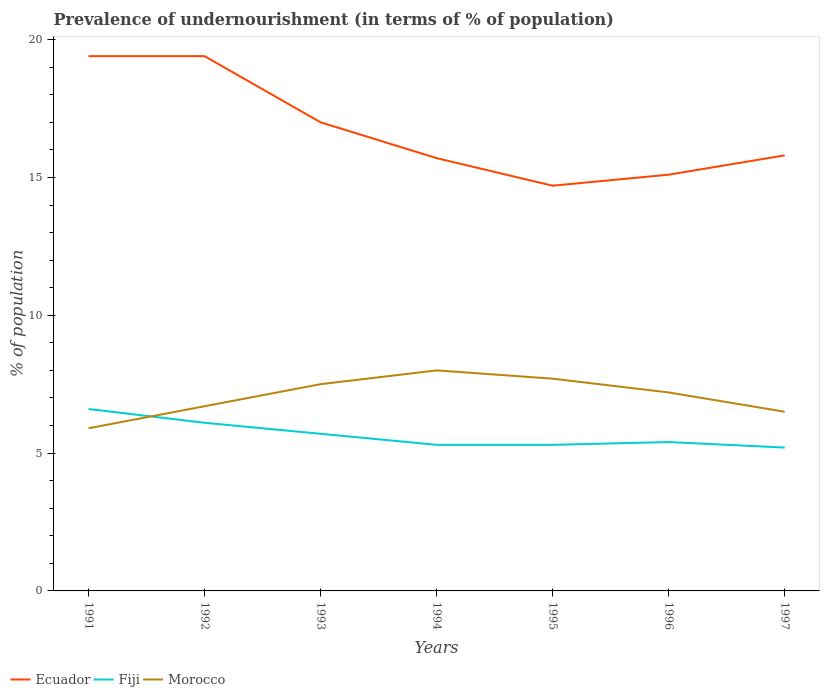Does the line corresponding to Morocco intersect with the line corresponding to Fiji?
Give a very brief answer. Yes. In which year was the percentage of undernourished population in Ecuador maximum?
Ensure brevity in your answer.  1995. What is the total percentage of undernourished population in Ecuador in the graph?
Your answer should be compact. 4.3. What is the difference between the highest and the second highest percentage of undernourished population in Morocco?
Provide a succinct answer. 2.1. What is the difference between the highest and the lowest percentage of undernourished population in Morocco?
Offer a terse response. 4. How many lines are there?
Your response must be concise. 3. How many years are there in the graph?
Keep it short and to the point. 7. What is the difference between two consecutive major ticks on the Y-axis?
Your response must be concise. 5. How many legend labels are there?
Your answer should be compact. 3. What is the title of the graph?
Your answer should be compact. Prevalence of undernourishment (in terms of % of population). Does "Panama" appear as one of the legend labels in the graph?
Your answer should be compact. No. What is the label or title of the X-axis?
Offer a terse response. Years. What is the label or title of the Y-axis?
Your answer should be compact. % of population. What is the % of population of Ecuador in 1991?
Offer a terse response. 19.4. What is the % of population in Fiji in 1991?
Offer a terse response. 6.6. What is the % of population of Morocco in 1991?
Your answer should be very brief. 5.9. What is the % of population in Fiji in 1992?
Your answer should be compact. 6.1. What is the % of population in Morocco in 1992?
Offer a very short reply. 6.7. What is the % of population of Fiji in 1993?
Offer a very short reply. 5.7. What is the % of population of Fiji in 1994?
Provide a succinct answer. 5.3. What is the % of population of Morocco in 1994?
Provide a short and direct response. 8. What is the % of population in Ecuador in 1995?
Keep it short and to the point. 14.7. What is the % of population of Fiji in 1995?
Provide a short and direct response. 5.3. What is the % of population in Morocco in 1995?
Ensure brevity in your answer.  7.7. What is the % of population of Ecuador in 1996?
Ensure brevity in your answer.  15.1. What is the % of population in Morocco in 1997?
Keep it short and to the point. 6.5. Across all years, what is the maximum % of population in Morocco?
Offer a terse response. 8. Across all years, what is the minimum % of population of Ecuador?
Your answer should be very brief. 14.7. Across all years, what is the minimum % of population of Fiji?
Provide a succinct answer. 5.2. Across all years, what is the minimum % of population of Morocco?
Offer a terse response. 5.9. What is the total % of population of Ecuador in the graph?
Your answer should be compact. 117.1. What is the total % of population of Fiji in the graph?
Keep it short and to the point. 39.6. What is the total % of population in Morocco in the graph?
Offer a very short reply. 49.5. What is the difference between the % of population in Ecuador in 1991 and that in 1992?
Your answer should be compact. 0. What is the difference between the % of population in Morocco in 1991 and that in 1992?
Offer a very short reply. -0.8. What is the difference between the % of population in Ecuador in 1991 and that in 1993?
Provide a short and direct response. 2.4. What is the difference between the % of population of Morocco in 1991 and that in 1993?
Give a very brief answer. -1.6. What is the difference between the % of population in Ecuador in 1991 and that in 1994?
Ensure brevity in your answer.  3.7. What is the difference between the % of population in Fiji in 1991 and that in 1995?
Your response must be concise. 1.3. What is the difference between the % of population in Morocco in 1991 and that in 1996?
Your answer should be very brief. -1.3. What is the difference between the % of population of Fiji in 1991 and that in 1997?
Your answer should be compact. 1.4. What is the difference between the % of population of Morocco in 1991 and that in 1997?
Your response must be concise. -0.6. What is the difference between the % of population in Ecuador in 1992 and that in 1993?
Your answer should be compact. 2.4. What is the difference between the % of population of Fiji in 1992 and that in 1993?
Your answer should be compact. 0.4. What is the difference between the % of population in Morocco in 1992 and that in 1993?
Make the answer very short. -0.8. What is the difference between the % of population of Fiji in 1992 and that in 1996?
Provide a succinct answer. 0.7. What is the difference between the % of population of Morocco in 1992 and that in 1996?
Provide a short and direct response. -0.5. What is the difference between the % of population of Fiji in 1992 and that in 1997?
Make the answer very short. 0.9. What is the difference between the % of population of Ecuador in 1993 and that in 1994?
Give a very brief answer. 1.3. What is the difference between the % of population of Fiji in 1993 and that in 1994?
Provide a succinct answer. 0.4. What is the difference between the % of population in Fiji in 1993 and that in 1995?
Make the answer very short. 0.4. What is the difference between the % of population of Morocco in 1993 and that in 1995?
Keep it short and to the point. -0.2. What is the difference between the % of population of Morocco in 1993 and that in 1996?
Provide a succinct answer. 0.3. What is the difference between the % of population of Ecuador in 1993 and that in 1997?
Your answer should be very brief. 1.2. What is the difference between the % of population of Ecuador in 1994 and that in 1995?
Ensure brevity in your answer.  1. What is the difference between the % of population of Fiji in 1994 and that in 1995?
Your response must be concise. 0. What is the difference between the % of population of Fiji in 1994 and that in 1996?
Your answer should be compact. -0.1. What is the difference between the % of population in Morocco in 1994 and that in 1997?
Make the answer very short. 1.5. What is the difference between the % of population in Ecuador in 1995 and that in 1996?
Offer a terse response. -0.4. What is the difference between the % of population of Morocco in 1995 and that in 1996?
Give a very brief answer. 0.5. What is the difference between the % of population in Ecuador in 1995 and that in 1997?
Keep it short and to the point. -1.1. What is the difference between the % of population in Fiji in 1995 and that in 1997?
Your answer should be compact. 0.1. What is the difference between the % of population of Morocco in 1995 and that in 1997?
Make the answer very short. 1.2. What is the difference between the % of population in Fiji in 1996 and that in 1997?
Keep it short and to the point. 0.2. What is the difference between the % of population in Morocco in 1996 and that in 1997?
Ensure brevity in your answer.  0.7. What is the difference between the % of population of Ecuador in 1991 and the % of population of Morocco in 1992?
Your answer should be very brief. 12.7. What is the difference between the % of population of Fiji in 1991 and the % of population of Morocco in 1992?
Your response must be concise. -0.1. What is the difference between the % of population of Ecuador in 1991 and the % of population of Fiji in 1993?
Provide a short and direct response. 13.7. What is the difference between the % of population in Ecuador in 1991 and the % of population in Morocco in 1993?
Your answer should be very brief. 11.9. What is the difference between the % of population in Fiji in 1991 and the % of population in Morocco in 1993?
Your response must be concise. -0.9. What is the difference between the % of population in Ecuador in 1991 and the % of population in Fiji in 1994?
Provide a succinct answer. 14.1. What is the difference between the % of population in Ecuador in 1991 and the % of population in Morocco in 1994?
Make the answer very short. 11.4. What is the difference between the % of population in Ecuador in 1991 and the % of population in Fiji in 1995?
Provide a short and direct response. 14.1. What is the difference between the % of population in Ecuador in 1991 and the % of population in Fiji in 1996?
Your response must be concise. 14. What is the difference between the % of population in Ecuador in 1991 and the % of population in Fiji in 1997?
Give a very brief answer. 14.2. What is the difference between the % of population in Ecuador in 1991 and the % of population in Morocco in 1997?
Provide a short and direct response. 12.9. What is the difference between the % of population of Fiji in 1991 and the % of population of Morocco in 1997?
Keep it short and to the point. 0.1. What is the difference between the % of population in Ecuador in 1992 and the % of population in Morocco in 1993?
Your answer should be compact. 11.9. What is the difference between the % of population in Ecuador in 1992 and the % of population in Fiji in 1994?
Offer a terse response. 14.1. What is the difference between the % of population in Ecuador in 1992 and the % of population in Morocco in 1994?
Provide a short and direct response. 11.4. What is the difference between the % of population of Ecuador in 1992 and the % of population of Fiji in 1995?
Your answer should be very brief. 14.1. What is the difference between the % of population of Ecuador in 1992 and the % of population of Fiji in 1996?
Make the answer very short. 14. What is the difference between the % of population in Ecuador in 1992 and the % of population in Fiji in 1997?
Your answer should be compact. 14.2. What is the difference between the % of population in Ecuador in 1992 and the % of population in Morocco in 1997?
Give a very brief answer. 12.9. What is the difference between the % of population in Fiji in 1992 and the % of population in Morocco in 1997?
Offer a terse response. -0.4. What is the difference between the % of population of Ecuador in 1993 and the % of population of Fiji in 1994?
Provide a succinct answer. 11.7. What is the difference between the % of population in Ecuador in 1993 and the % of population in Morocco in 1994?
Provide a short and direct response. 9. What is the difference between the % of population in Fiji in 1993 and the % of population in Morocco in 1994?
Ensure brevity in your answer.  -2.3. What is the difference between the % of population in Ecuador in 1993 and the % of population in Morocco in 1995?
Your response must be concise. 9.3. What is the difference between the % of population of Ecuador in 1993 and the % of population of Morocco in 1996?
Your answer should be very brief. 9.8. What is the difference between the % of population of Ecuador in 1993 and the % of population of Fiji in 1997?
Make the answer very short. 11.8. What is the difference between the % of population in Ecuador in 1993 and the % of population in Morocco in 1997?
Offer a terse response. 10.5. What is the difference between the % of population of Fiji in 1993 and the % of population of Morocco in 1997?
Ensure brevity in your answer.  -0.8. What is the difference between the % of population in Ecuador in 1994 and the % of population in Fiji in 1995?
Offer a terse response. 10.4. What is the difference between the % of population in Ecuador in 1994 and the % of population in Morocco in 1995?
Make the answer very short. 8. What is the difference between the % of population of Ecuador in 1994 and the % of population of Fiji in 1996?
Your answer should be compact. 10.3. What is the difference between the % of population of Ecuador in 1994 and the % of population of Morocco in 1996?
Provide a succinct answer. 8.5. What is the difference between the % of population in Fiji in 1994 and the % of population in Morocco in 1996?
Make the answer very short. -1.9. What is the difference between the % of population of Ecuador in 1994 and the % of population of Fiji in 1997?
Your answer should be compact. 10.5. What is the difference between the % of population in Ecuador in 1994 and the % of population in Morocco in 1997?
Offer a terse response. 9.2. What is the difference between the % of population in Fiji in 1994 and the % of population in Morocco in 1997?
Give a very brief answer. -1.2. What is the difference between the % of population of Ecuador in 1995 and the % of population of Fiji in 1996?
Your answer should be very brief. 9.3. What is the difference between the % of population in Fiji in 1995 and the % of population in Morocco in 1996?
Give a very brief answer. -1.9. What is the difference between the % of population in Ecuador in 1995 and the % of population in Morocco in 1997?
Provide a short and direct response. 8.2. What is the difference between the % of population in Ecuador in 1996 and the % of population in Morocco in 1997?
Your answer should be very brief. 8.6. What is the difference between the % of population of Fiji in 1996 and the % of population of Morocco in 1997?
Your response must be concise. -1.1. What is the average % of population of Ecuador per year?
Offer a terse response. 16.73. What is the average % of population of Fiji per year?
Offer a very short reply. 5.66. What is the average % of population of Morocco per year?
Your answer should be very brief. 7.07. In the year 1991, what is the difference between the % of population in Ecuador and % of population in Fiji?
Your answer should be very brief. 12.8. In the year 1991, what is the difference between the % of population of Ecuador and % of population of Morocco?
Provide a short and direct response. 13.5. In the year 1992, what is the difference between the % of population of Ecuador and % of population of Morocco?
Provide a succinct answer. 12.7. In the year 1992, what is the difference between the % of population of Fiji and % of population of Morocco?
Keep it short and to the point. -0.6. In the year 1993, what is the difference between the % of population in Ecuador and % of population in Fiji?
Provide a succinct answer. 11.3. In the year 1993, what is the difference between the % of population of Ecuador and % of population of Morocco?
Your answer should be very brief. 9.5. In the year 1993, what is the difference between the % of population in Fiji and % of population in Morocco?
Ensure brevity in your answer.  -1.8. In the year 1994, what is the difference between the % of population of Ecuador and % of population of Morocco?
Provide a succinct answer. 7.7. In the year 1994, what is the difference between the % of population in Fiji and % of population in Morocco?
Keep it short and to the point. -2.7. In the year 1995, what is the difference between the % of population of Ecuador and % of population of Fiji?
Your answer should be very brief. 9.4. In the year 1995, what is the difference between the % of population in Ecuador and % of population in Morocco?
Your response must be concise. 7. In the year 1995, what is the difference between the % of population of Fiji and % of population of Morocco?
Keep it short and to the point. -2.4. In the year 1996, what is the difference between the % of population in Ecuador and % of population in Fiji?
Make the answer very short. 9.7. In the year 1997, what is the difference between the % of population in Ecuador and % of population in Morocco?
Provide a succinct answer. 9.3. What is the ratio of the % of population of Fiji in 1991 to that in 1992?
Offer a very short reply. 1.08. What is the ratio of the % of population of Morocco in 1991 to that in 1992?
Ensure brevity in your answer.  0.88. What is the ratio of the % of population of Ecuador in 1991 to that in 1993?
Provide a succinct answer. 1.14. What is the ratio of the % of population of Fiji in 1991 to that in 1993?
Give a very brief answer. 1.16. What is the ratio of the % of population in Morocco in 1991 to that in 1993?
Your response must be concise. 0.79. What is the ratio of the % of population in Ecuador in 1991 to that in 1994?
Give a very brief answer. 1.24. What is the ratio of the % of population in Fiji in 1991 to that in 1994?
Your response must be concise. 1.25. What is the ratio of the % of population of Morocco in 1991 to that in 1994?
Make the answer very short. 0.74. What is the ratio of the % of population in Ecuador in 1991 to that in 1995?
Your answer should be compact. 1.32. What is the ratio of the % of population in Fiji in 1991 to that in 1995?
Keep it short and to the point. 1.25. What is the ratio of the % of population of Morocco in 1991 to that in 1995?
Provide a succinct answer. 0.77. What is the ratio of the % of population of Ecuador in 1991 to that in 1996?
Your answer should be very brief. 1.28. What is the ratio of the % of population of Fiji in 1991 to that in 1996?
Offer a very short reply. 1.22. What is the ratio of the % of population of Morocco in 1991 to that in 1996?
Your answer should be very brief. 0.82. What is the ratio of the % of population in Ecuador in 1991 to that in 1997?
Your answer should be very brief. 1.23. What is the ratio of the % of population in Fiji in 1991 to that in 1997?
Offer a very short reply. 1.27. What is the ratio of the % of population of Morocco in 1991 to that in 1997?
Your answer should be compact. 0.91. What is the ratio of the % of population in Ecuador in 1992 to that in 1993?
Provide a short and direct response. 1.14. What is the ratio of the % of population in Fiji in 1992 to that in 1993?
Offer a terse response. 1.07. What is the ratio of the % of population in Morocco in 1992 to that in 1993?
Provide a succinct answer. 0.89. What is the ratio of the % of population in Ecuador in 1992 to that in 1994?
Your answer should be very brief. 1.24. What is the ratio of the % of population in Fiji in 1992 to that in 1994?
Ensure brevity in your answer.  1.15. What is the ratio of the % of population in Morocco in 1992 to that in 1994?
Offer a terse response. 0.84. What is the ratio of the % of population in Ecuador in 1992 to that in 1995?
Your response must be concise. 1.32. What is the ratio of the % of population of Fiji in 1992 to that in 1995?
Give a very brief answer. 1.15. What is the ratio of the % of population in Morocco in 1992 to that in 1995?
Offer a terse response. 0.87. What is the ratio of the % of population in Ecuador in 1992 to that in 1996?
Your answer should be compact. 1.28. What is the ratio of the % of population in Fiji in 1992 to that in 1996?
Make the answer very short. 1.13. What is the ratio of the % of population in Morocco in 1992 to that in 1996?
Give a very brief answer. 0.93. What is the ratio of the % of population in Ecuador in 1992 to that in 1997?
Give a very brief answer. 1.23. What is the ratio of the % of population in Fiji in 1992 to that in 1997?
Offer a very short reply. 1.17. What is the ratio of the % of population in Morocco in 1992 to that in 1997?
Provide a short and direct response. 1.03. What is the ratio of the % of population in Ecuador in 1993 to that in 1994?
Offer a very short reply. 1.08. What is the ratio of the % of population of Fiji in 1993 to that in 1994?
Make the answer very short. 1.08. What is the ratio of the % of population in Morocco in 1993 to that in 1994?
Your response must be concise. 0.94. What is the ratio of the % of population in Ecuador in 1993 to that in 1995?
Offer a very short reply. 1.16. What is the ratio of the % of population in Fiji in 1993 to that in 1995?
Provide a short and direct response. 1.08. What is the ratio of the % of population in Ecuador in 1993 to that in 1996?
Offer a very short reply. 1.13. What is the ratio of the % of population of Fiji in 1993 to that in 1996?
Provide a succinct answer. 1.06. What is the ratio of the % of population in Morocco in 1993 to that in 1996?
Keep it short and to the point. 1.04. What is the ratio of the % of population in Ecuador in 1993 to that in 1997?
Provide a short and direct response. 1.08. What is the ratio of the % of population of Fiji in 1993 to that in 1997?
Give a very brief answer. 1.1. What is the ratio of the % of population of Morocco in 1993 to that in 1997?
Offer a terse response. 1.15. What is the ratio of the % of population of Ecuador in 1994 to that in 1995?
Your answer should be compact. 1.07. What is the ratio of the % of population of Fiji in 1994 to that in 1995?
Provide a succinct answer. 1. What is the ratio of the % of population of Morocco in 1994 to that in 1995?
Your answer should be very brief. 1.04. What is the ratio of the % of population in Ecuador in 1994 to that in 1996?
Make the answer very short. 1.04. What is the ratio of the % of population of Fiji in 1994 to that in 1996?
Provide a short and direct response. 0.98. What is the ratio of the % of population in Morocco in 1994 to that in 1996?
Provide a succinct answer. 1.11. What is the ratio of the % of population of Ecuador in 1994 to that in 1997?
Make the answer very short. 0.99. What is the ratio of the % of population of Fiji in 1994 to that in 1997?
Provide a succinct answer. 1.02. What is the ratio of the % of population in Morocco in 1994 to that in 1997?
Offer a terse response. 1.23. What is the ratio of the % of population of Ecuador in 1995 to that in 1996?
Your answer should be very brief. 0.97. What is the ratio of the % of population of Fiji in 1995 to that in 1996?
Your response must be concise. 0.98. What is the ratio of the % of population in Morocco in 1995 to that in 1996?
Your response must be concise. 1.07. What is the ratio of the % of population in Ecuador in 1995 to that in 1997?
Provide a short and direct response. 0.93. What is the ratio of the % of population of Fiji in 1995 to that in 1997?
Ensure brevity in your answer.  1.02. What is the ratio of the % of population of Morocco in 1995 to that in 1997?
Offer a terse response. 1.18. What is the ratio of the % of population of Ecuador in 1996 to that in 1997?
Provide a short and direct response. 0.96. What is the ratio of the % of population in Fiji in 1996 to that in 1997?
Make the answer very short. 1.04. What is the ratio of the % of population of Morocco in 1996 to that in 1997?
Make the answer very short. 1.11. What is the difference between the highest and the second highest % of population of Ecuador?
Give a very brief answer. 0. What is the difference between the highest and the lowest % of population of Morocco?
Ensure brevity in your answer.  2.1. 